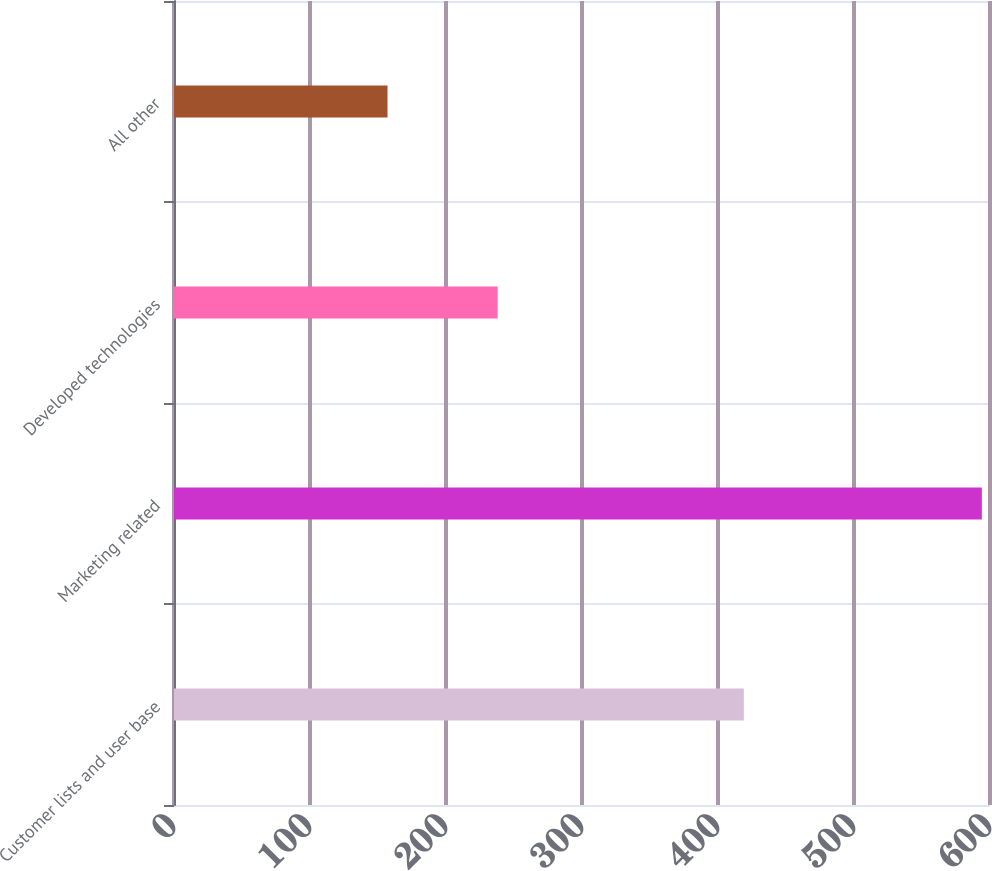Convert chart. <chart><loc_0><loc_0><loc_500><loc_500><bar_chart><fcel>Customer lists and user base<fcel>Marketing related<fcel>Developed technologies<fcel>All other<nl><fcel>419<fcel>594<fcel>238<fcel>157<nl></chart> 